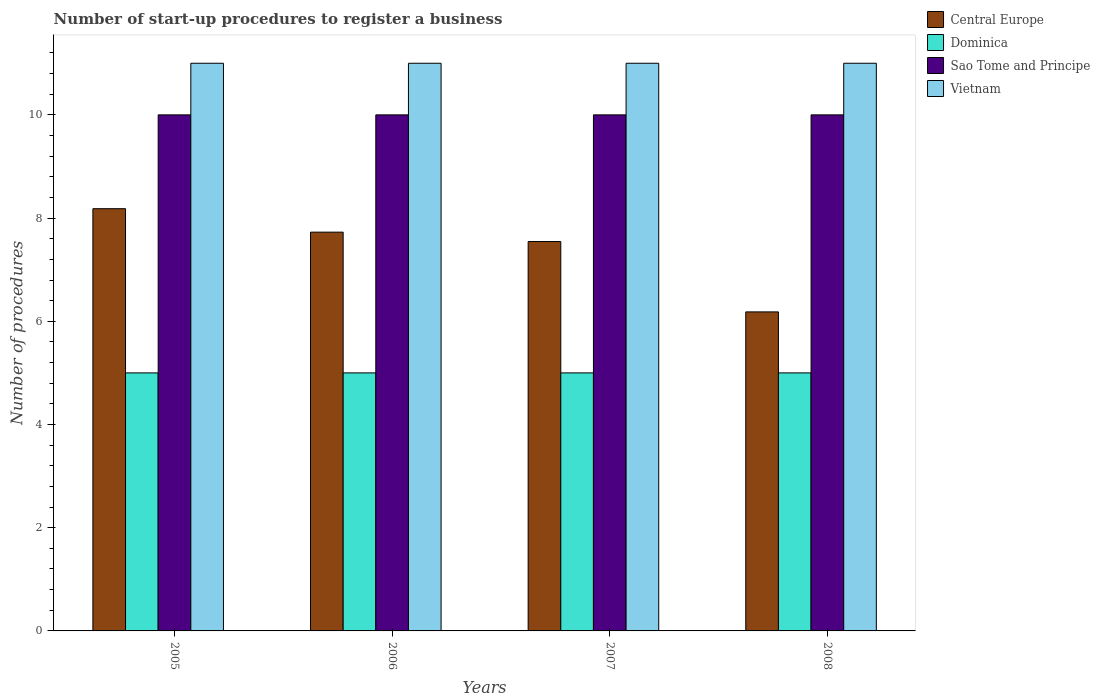How many bars are there on the 4th tick from the left?
Your answer should be compact. 4. How many bars are there on the 1st tick from the right?
Your answer should be compact. 4. What is the number of procedures required to register a business in Central Europe in 2008?
Give a very brief answer. 6.18. Across all years, what is the maximum number of procedures required to register a business in Dominica?
Make the answer very short. 5. Across all years, what is the minimum number of procedures required to register a business in Sao Tome and Principe?
Your response must be concise. 10. What is the total number of procedures required to register a business in Vietnam in the graph?
Offer a very short reply. 44. What is the difference between the number of procedures required to register a business in Central Europe in 2006 and that in 2007?
Make the answer very short. 0.18. What is the average number of procedures required to register a business in Vietnam per year?
Give a very brief answer. 11. In the year 2008, what is the difference between the number of procedures required to register a business in Dominica and number of procedures required to register a business in Central Europe?
Your response must be concise. -1.18. What is the difference between the highest and the second highest number of procedures required to register a business in Sao Tome and Principe?
Provide a succinct answer. 0. What is the difference between the highest and the lowest number of procedures required to register a business in Dominica?
Your response must be concise. 0. In how many years, is the number of procedures required to register a business in Dominica greater than the average number of procedures required to register a business in Dominica taken over all years?
Your answer should be very brief. 0. Is the sum of the number of procedures required to register a business in Dominica in 2006 and 2008 greater than the maximum number of procedures required to register a business in Central Europe across all years?
Your answer should be compact. Yes. Is it the case that in every year, the sum of the number of procedures required to register a business in Dominica and number of procedures required to register a business in Vietnam is greater than the sum of number of procedures required to register a business in Sao Tome and Principe and number of procedures required to register a business in Central Europe?
Provide a short and direct response. Yes. What does the 2nd bar from the left in 2007 represents?
Ensure brevity in your answer.  Dominica. What does the 3rd bar from the right in 2005 represents?
Keep it short and to the point. Dominica. How many bars are there?
Provide a succinct answer. 16. Are all the bars in the graph horizontal?
Provide a succinct answer. No. Are the values on the major ticks of Y-axis written in scientific E-notation?
Provide a succinct answer. No. Does the graph contain any zero values?
Your answer should be very brief. No. Does the graph contain grids?
Make the answer very short. No. Where does the legend appear in the graph?
Your response must be concise. Top right. What is the title of the graph?
Offer a terse response. Number of start-up procedures to register a business. Does "Malaysia" appear as one of the legend labels in the graph?
Provide a succinct answer. No. What is the label or title of the Y-axis?
Ensure brevity in your answer.  Number of procedures. What is the Number of procedures of Central Europe in 2005?
Give a very brief answer. 8.18. What is the Number of procedures in Vietnam in 2005?
Make the answer very short. 11. What is the Number of procedures of Central Europe in 2006?
Make the answer very short. 7.73. What is the Number of procedures in Dominica in 2006?
Offer a very short reply. 5. What is the Number of procedures of Sao Tome and Principe in 2006?
Make the answer very short. 10. What is the Number of procedures of Vietnam in 2006?
Your response must be concise. 11. What is the Number of procedures of Central Europe in 2007?
Your response must be concise. 7.55. What is the Number of procedures of Dominica in 2007?
Provide a short and direct response. 5. What is the Number of procedures of Sao Tome and Principe in 2007?
Your answer should be compact. 10. What is the Number of procedures in Central Europe in 2008?
Give a very brief answer. 6.18. What is the Number of procedures in Sao Tome and Principe in 2008?
Your answer should be very brief. 10. What is the Number of procedures of Vietnam in 2008?
Make the answer very short. 11. Across all years, what is the maximum Number of procedures of Central Europe?
Offer a terse response. 8.18. Across all years, what is the maximum Number of procedures in Dominica?
Your answer should be compact. 5. Across all years, what is the maximum Number of procedures in Sao Tome and Principe?
Your response must be concise. 10. Across all years, what is the maximum Number of procedures of Vietnam?
Your response must be concise. 11. Across all years, what is the minimum Number of procedures of Central Europe?
Ensure brevity in your answer.  6.18. Across all years, what is the minimum Number of procedures in Dominica?
Your answer should be compact. 5. Across all years, what is the minimum Number of procedures of Vietnam?
Make the answer very short. 11. What is the total Number of procedures in Central Europe in the graph?
Offer a terse response. 29.64. What is the total Number of procedures of Dominica in the graph?
Your answer should be very brief. 20. What is the total Number of procedures in Sao Tome and Principe in the graph?
Your answer should be very brief. 40. What is the difference between the Number of procedures in Central Europe in 2005 and that in 2006?
Provide a short and direct response. 0.45. What is the difference between the Number of procedures of Dominica in 2005 and that in 2006?
Your answer should be very brief. 0. What is the difference between the Number of procedures in Sao Tome and Principe in 2005 and that in 2006?
Your response must be concise. 0. What is the difference between the Number of procedures of Vietnam in 2005 and that in 2006?
Keep it short and to the point. 0. What is the difference between the Number of procedures of Central Europe in 2005 and that in 2007?
Your answer should be compact. 0.64. What is the difference between the Number of procedures in Sao Tome and Principe in 2005 and that in 2007?
Make the answer very short. 0. What is the difference between the Number of procedures in Vietnam in 2005 and that in 2007?
Ensure brevity in your answer.  0. What is the difference between the Number of procedures in Central Europe in 2005 and that in 2008?
Keep it short and to the point. 2. What is the difference between the Number of procedures in Dominica in 2005 and that in 2008?
Your answer should be compact. 0. What is the difference between the Number of procedures in Sao Tome and Principe in 2005 and that in 2008?
Your answer should be compact. 0. What is the difference between the Number of procedures in Vietnam in 2005 and that in 2008?
Your answer should be compact. 0. What is the difference between the Number of procedures of Central Europe in 2006 and that in 2007?
Make the answer very short. 0.18. What is the difference between the Number of procedures of Dominica in 2006 and that in 2007?
Offer a terse response. 0. What is the difference between the Number of procedures of Central Europe in 2006 and that in 2008?
Offer a very short reply. 1.55. What is the difference between the Number of procedures in Dominica in 2006 and that in 2008?
Your response must be concise. 0. What is the difference between the Number of procedures in Central Europe in 2007 and that in 2008?
Keep it short and to the point. 1.36. What is the difference between the Number of procedures of Dominica in 2007 and that in 2008?
Provide a succinct answer. 0. What is the difference between the Number of procedures in Vietnam in 2007 and that in 2008?
Your response must be concise. 0. What is the difference between the Number of procedures of Central Europe in 2005 and the Number of procedures of Dominica in 2006?
Offer a very short reply. 3.18. What is the difference between the Number of procedures of Central Europe in 2005 and the Number of procedures of Sao Tome and Principe in 2006?
Provide a succinct answer. -1.82. What is the difference between the Number of procedures in Central Europe in 2005 and the Number of procedures in Vietnam in 2006?
Provide a short and direct response. -2.82. What is the difference between the Number of procedures in Central Europe in 2005 and the Number of procedures in Dominica in 2007?
Provide a succinct answer. 3.18. What is the difference between the Number of procedures in Central Europe in 2005 and the Number of procedures in Sao Tome and Principe in 2007?
Make the answer very short. -1.82. What is the difference between the Number of procedures in Central Europe in 2005 and the Number of procedures in Vietnam in 2007?
Provide a short and direct response. -2.82. What is the difference between the Number of procedures in Dominica in 2005 and the Number of procedures in Sao Tome and Principe in 2007?
Give a very brief answer. -5. What is the difference between the Number of procedures of Dominica in 2005 and the Number of procedures of Vietnam in 2007?
Keep it short and to the point. -6. What is the difference between the Number of procedures of Central Europe in 2005 and the Number of procedures of Dominica in 2008?
Provide a short and direct response. 3.18. What is the difference between the Number of procedures in Central Europe in 2005 and the Number of procedures in Sao Tome and Principe in 2008?
Provide a short and direct response. -1.82. What is the difference between the Number of procedures in Central Europe in 2005 and the Number of procedures in Vietnam in 2008?
Your answer should be very brief. -2.82. What is the difference between the Number of procedures in Sao Tome and Principe in 2005 and the Number of procedures in Vietnam in 2008?
Offer a terse response. -1. What is the difference between the Number of procedures of Central Europe in 2006 and the Number of procedures of Dominica in 2007?
Ensure brevity in your answer.  2.73. What is the difference between the Number of procedures in Central Europe in 2006 and the Number of procedures in Sao Tome and Principe in 2007?
Your answer should be very brief. -2.27. What is the difference between the Number of procedures of Central Europe in 2006 and the Number of procedures of Vietnam in 2007?
Provide a succinct answer. -3.27. What is the difference between the Number of procedures of Sao Tome and Principe in 2006 and the Number of procedures of Vietnam in 2007?
Your answer should be compact. -1. What is the difference between the Number of procedures in Central Europe in 2006 and the Number of procedures in Dominica in 2008?
Offer a terse response. 2.73. What is the difference between the Number of procedures in Central Europe in 2006 and the Number of procedures in Sao Tome and Principe in 2008?
Your response must be concise. -2.27. What is the difference between the Number of procedures in Central Europe in 2006 and the Number of procedures in Vietnam in 2008?
Give a very brief answer. -3.27. What is the difference between the Number of procedures of Central Europe in 2007 and the Number of procedures of Dominica in 2008?
Your answer should be very brief. 2.55. What is the difference between the Number of procedures of Central Europe in 2007 and the Number of procedures of Sao Tome and Principe in 2008?
Your answer should be compact. -2.45. What is the difference between the Number of procedures of Central Europe in 2007 and the Number of procedures of Vietnam in 2008?
Your answer should be compact. -3.45. What is the difference between the Number of procedures of Dominica in 2007 and the Number of procedures of Sao Tome and Principe in 2008?
Offer a very short reply. -5. What is the difference between the Number of procedures in Dominica in 2007 and the Number of procedures in Vietnam in 2008?
Offer a terse response. -6. What is the difference between the Number of procedures in Sao Tome and Principe in 2007 and the Number of procedures in Vietnam in 2008?
Make the answer very short. -1. What is the average Number of procedures in Central Europe per year?
Ensure brevity in your answer.  7.41. What is the average Number of procedures of Dominica per year?
Keep it short and to the point. 5. What is the average Number of procedures of Vietnam per year?
Ensure brevity in your answer.  11. In the year 2005, what is the difference between the Number of procedures in Central Europe and Number of procedures in Dominica?
Offer a very short reply. 3.18. In the year 2005, what is the difference between the Number of procedures of Central Europe and Number of procedures of Sao Tome and Principe?
Keep it short and to the point. -1.82. In the year 2005, what is the difference between the Number of procedures in Central Europe and Number of procedures in Vietnam?
Your answer should be compact. -2.82. In the year 2005, what is the difference between the Number of procedures of Dominica and Number of procedures of Sao Tome and Principe?
Offer a very short reply. -5. In the year 2006, what is the difference between the Number of procedures of Central Europe and Number of procedures of Dominica?
Provide a succinct answer. 2.73. In the year 2006, what is the difference between the Number of procedures of Central Europe and Number of procedures of Sao Tome and Principe?
Provide a succinct answer. -2.27. In the year 2006, what is the difference between the Number of procedures of Central Europe and Number of procedures of Vietnam?
Provide a succinct answer. -3.27. In the year 2006, what is the difference between the Number of procedures of Dominica and Number of procedures of Sao Tome and Principe?
Offer a terse response. -5. In the year 2007, what is the difference between the Number of procedures in Central Europe and Number of procedures in Dominica?
Keep it short and to the point. 2.55. In the year 2007, what is the difference between the Number of procedures of Central Europe and Number of procedures of Sao Tome and Principe?
Provide a short and direct response. -2.45. In the year 2007, what is the difference between the Number of procedures of Central Europe and Number of procedures of Vietnam?
Offer a terse response. -3.45. In the year 2007, what is the difference between the Number of procedures of Dominica and Number of procedures of Vietnam?
Provide a succinct answer. -6. In the year 2008, what is the difference between the Number of procedures in Central Europe and Number of procedures in Dominica?
Provide a succinct answer. 1.18. In the year 2008, what is the difference between the Number of procedures in Central Europe and Number of procedures in Sao Tome and Principe?
Ensure brevity in your answer.  -3.82. In the year 2008, what is the difference between the Number of procedures of Central Europe and Number of procedures of Vietnam?
Offer a very short reply. -4.82. In the year 2008, what is the difference between the Number of procedures of Dominica and Number of procedures of Sao Tome and Principe?
Offer a very short reply. -5. In the year 2008, what is the difference between the Number of procedures of Dominica and Number of procedures of Vietnam?
Your answer should be compact. -6. What is the ratio of the Number of procedures of Central Europe in 2005 to that in 2006?
Keep it short and to the point. 1.06. What is the ratio of the Number of procedures of Dominica in 2005 to that in 2006?
Keep it short and to the point. 1. What is the ratio of the Number of procedures of Sao Tome and Principe in 2005 to that in 2006?
Provide a succinct answer. 1. What is the ratio of the Number of procedures of Vietnam in 2005 to that in 2006?
Offer a terse response. 1. What is the ratio of the Number of procedures in Central Europe in 2005 to that in 2007?
Ensure brevity in your answer.  1.08. What is the ratio of the Number of procedures of Dominica in 2005 to that in 2007?
Your response must be concise. 1. What is the ratio of the Number of procedures of Vietnam in 2005 to that in 2007?
Ensure brevity in your answer.  1. What is the ratio of the Number of procedures of Central Europe in 2005 to that in 2008?
Offer a very short reply. 1.32. What is the ratio of the Number of procedures of Dominica in 2005 to that in 2008?
Your answer should be very brief. 1. What is the ratio of the Number of procedures in Sao Tome and Principe in 2005 to that in 2008?
Provide a succinct answer. 1. What is the ratio of the Number of procedures of Vietnam in 2005 to that in 2008?
Your response must be concise. 1. What is the ratio of the Number of procedures in Central Europe in 2006 to that in 2007?
Your answer should be very brief. 1.02. What is the ratio of the Number of procedures of Sao Tome and Principe in 2006 to that in 2007?
Your answer should be very brief. 1. What is the ratio of the Number of procedures of Sao Tome and Principe in 2006 to that in 2008?
Offer a terse response. 1. What is the ratio of the Number of procedures in Central Europe in 2007 to that in 2008?
Your answer should be compact. 1.22. What is the ratio of the Number of procedures in Dominica in 2007 to that in 2008?
Offer a very short reply. 1. What is the ratio of the Number of procedures of Vietnam in 2007 to that in 2008?
Provide a succinct answer. 1. What is the difference between the highest and the second highest Number of procedures in Central Europe?
Provide a succinct answer. 0.45. What is the difference between the highest and the second highest Number of procedures of Sao Tome and Principe?
Your response must be concise. 0. What is the difference between the highest and the lowest Number of procedures in Central Europe?
Your answer should be very brief. 2. What is the difference between the highest and the lowest Number of procedures of Sao Tome and Principe?
Your response must be concise. 0. 